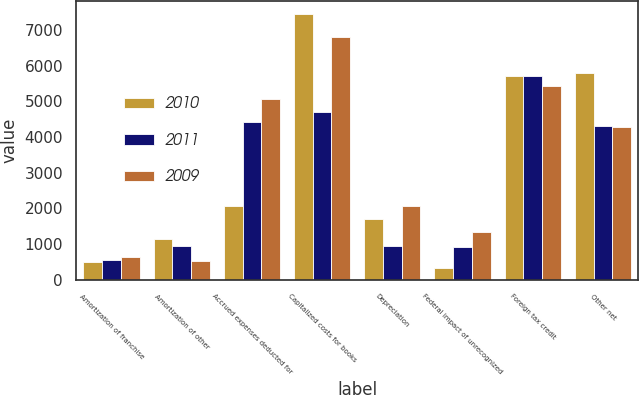Convert chart. <chart><loc_0><loc_0><loc_500><loc_500><stacked_bar_chart><ecel><fcel>Amortization of franchise<fcel>Amortization of other<fcel>Accrued expenses deducted for<fcel>Capitalized costs for books<fcel>Depreciation<fcel>Federal impact of unrecognized<fcel>Foreign tax credit<fcel>Other net<nl><fcel>2010<fcel>514<fcel>1142<fcel>2076<fcel>7448<fcel>1709<fcel>331<fcel>5719<fcel>5787<nl><fcel>2011<fcel>570<fcel>961<fcel>4423<fcel>4693<fcel>951<fcel>921<fcel>5719<fcel>4314<nl><fcel>2009<fcel>628<fcel>535<fcel>5069<fcel>6809<fcel>2076<fcel>1353<fcel>5434<fcel>4272<nl></chart> 